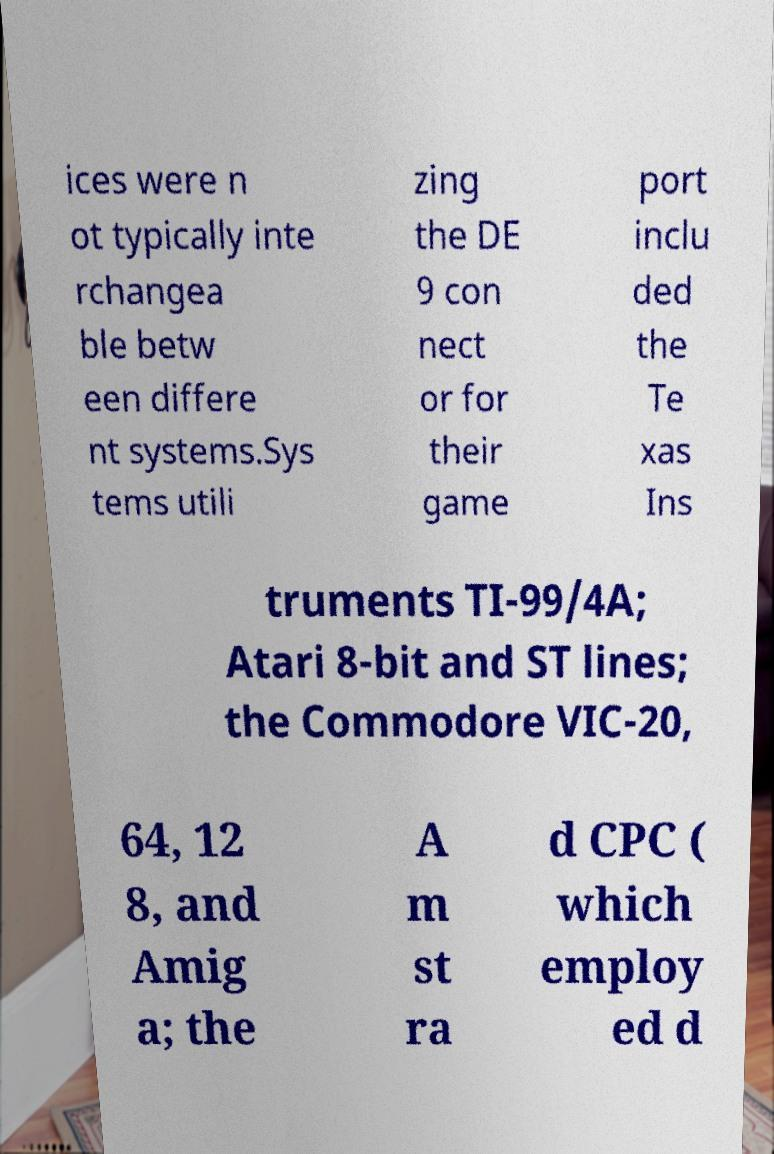There's text embedded in this image that I need extracted. Can you transcribe it verbatim? ices were n ot typically inte rchangea ble betw een differe nt systems.Sys tems utili zing the DE 9 con nect or for their game port inclu ded the Te xas Ins truments TI-99/4A; Atari 8-bit and ST lines; the Commodore VIC-20, 64, 12 8, and Amig a; the A m st ra d CPC ( which employ ed d 